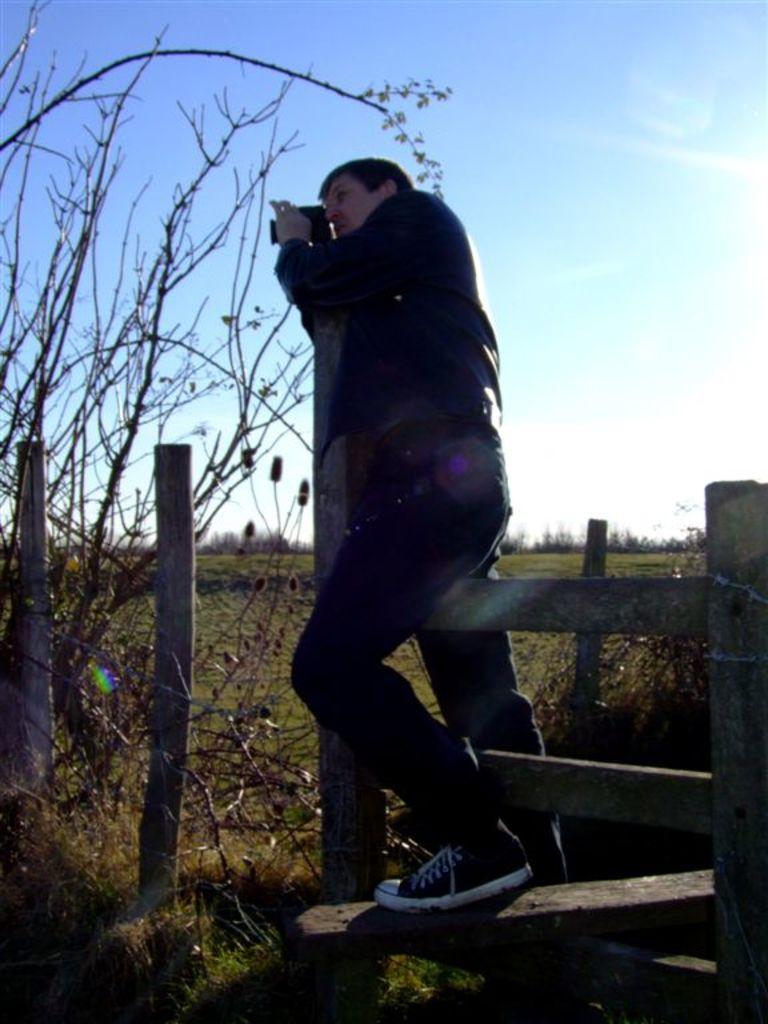Please provide a concise description of this image. In this I can see a person standing on wooden fence and in the background I can see the sky and on the left side I can see tree and a person holding a camera 